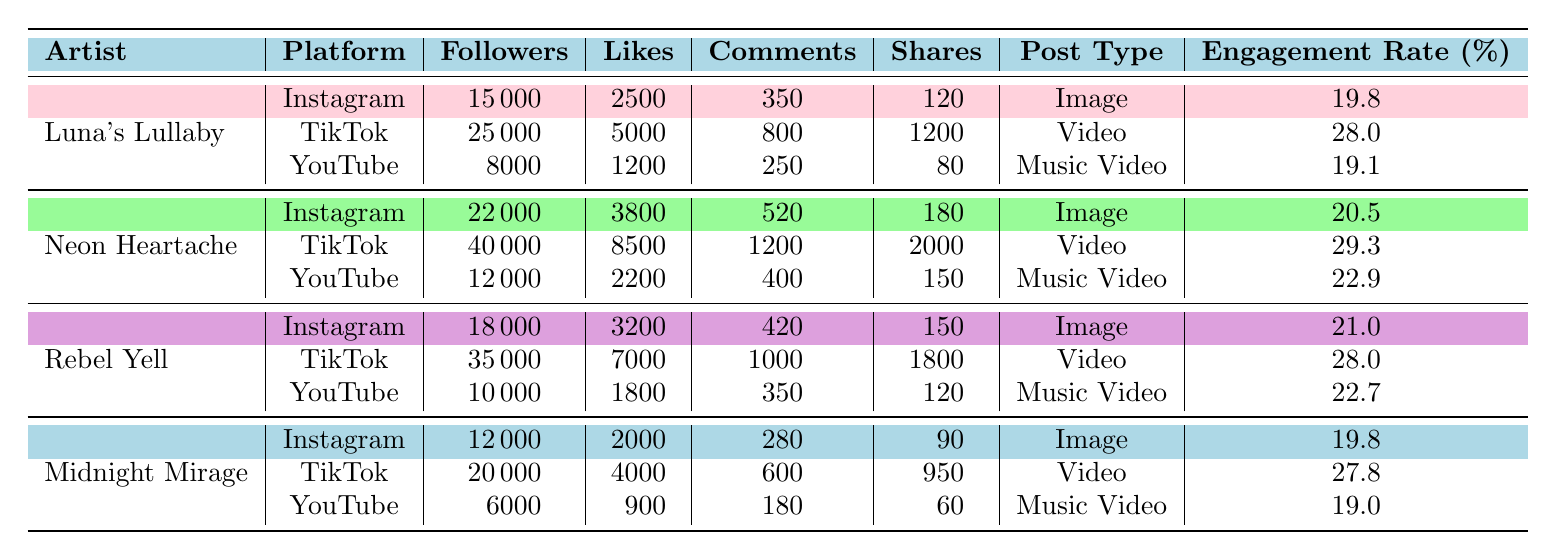What is the engagement rate of Neon Heartache on TikTok? From the table, we can find the row for Neon Heartache under the TikTok platform. The engagement rate for that specific entry is listed as 29.3%.
Answer: 29.3% Which artist has the highest number of followers on Instagram? By examining the Instagram row of each artist in the table, Neon Heartache has 22,000 followers, Luna's Lullaby has 15,000, Rebel Yell has 18,000, and Midnight Mirage has 12,000. The highest number of followers is thus 22,000 from Neon Heartache.
Answer: 22,000 How many total shares did Luna's Lullaby receive across all platforms? We look at the shares for Luna's Lullaby across each of the three platforms: Instagram has 120 shares, TikTok has 1200 shares, and YouTube has 80 shares. We sum these values: 120 + 1200 + 80 = 1400 shares total.
Answer: 1400 Is the engagement rate for Rebel Yell on Instagram higher than that on YouTube? To determine this, we check Rebel Yell's engagement rate for Instagram, which is 21.0%, compared to YouTube's engagement rate of 22.7%. Since 21.0% is less than 22.7%, the statement is false.
Answer: No What is the average engagement rate for all artists on TikTok? First, we list the engagement rates for all artists on TikTok: Luna's Lullaby is 28.0%, Neon Heartache is 29.3%, Rebel Yell is 28.0%, and Midnight Mirage is 27.8%. We then calculate the average by summing these: 28.0 + 29.3 + 28.0 + 27.8 = 113.1, and divide by 4 (the number of artists) to find 113.1 / 4 = 28.275%.
Answer: 28.3% 